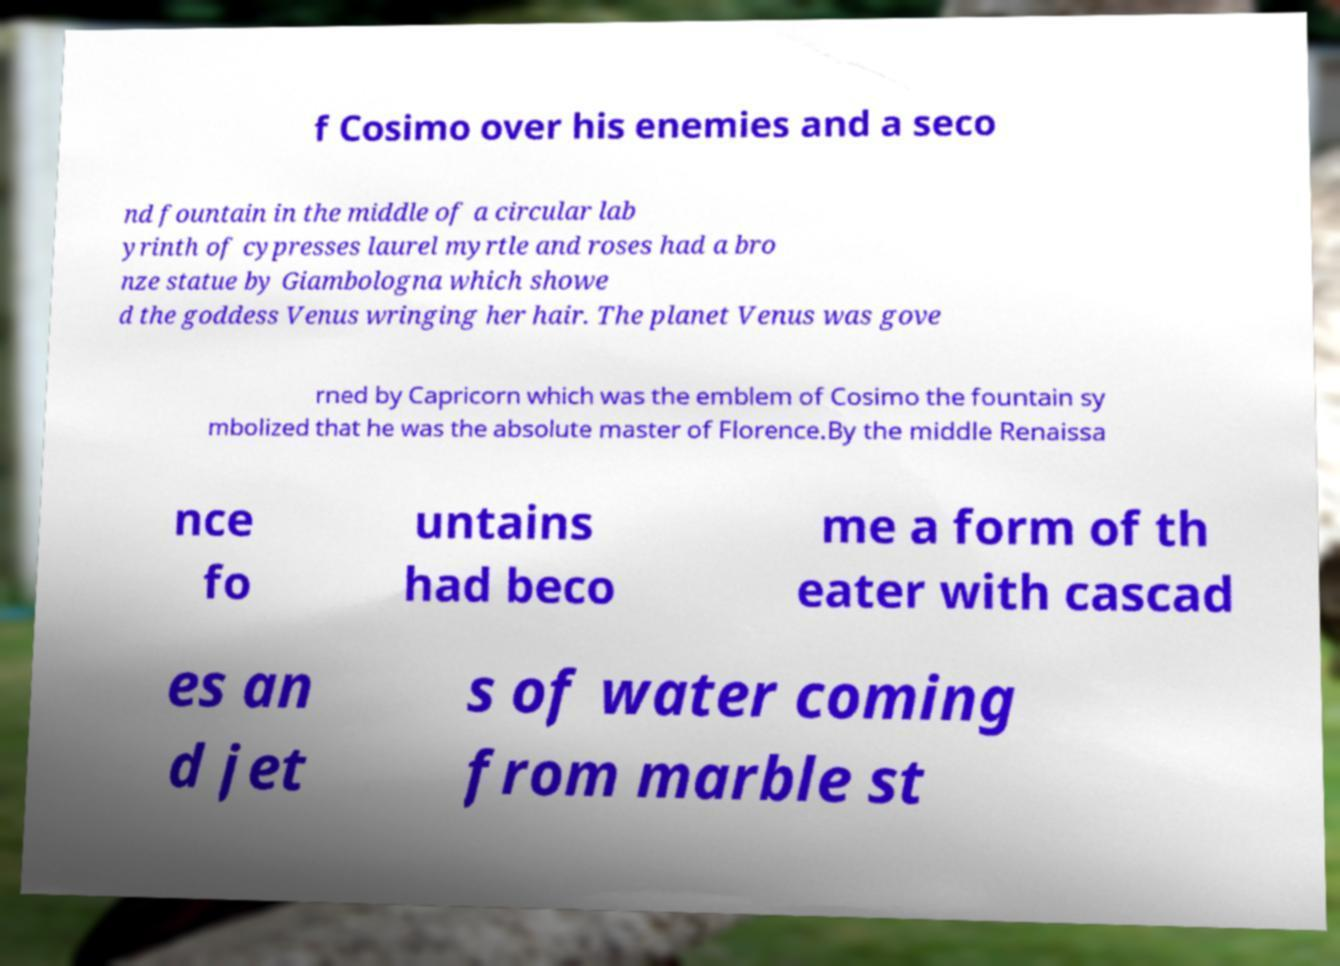Please read and relay the text visible in this image. What does it say? f Cosimo over his enemies and a seco nd fountain in the middle of a circular lab yrinth of cypresses laurel myrtle and roses had a bro nze statue by Giambologna which showe d the goddess Venus wringing her hair. The planet Venus was gove rned by Capricorn which was the emblem of Cosimo the fountain sy mbolized that he was the absolute master of Florence.By the middle Renaissa nce fo untains had beco me a form of th eater with cascad es an d jet s of water coming from marble st 